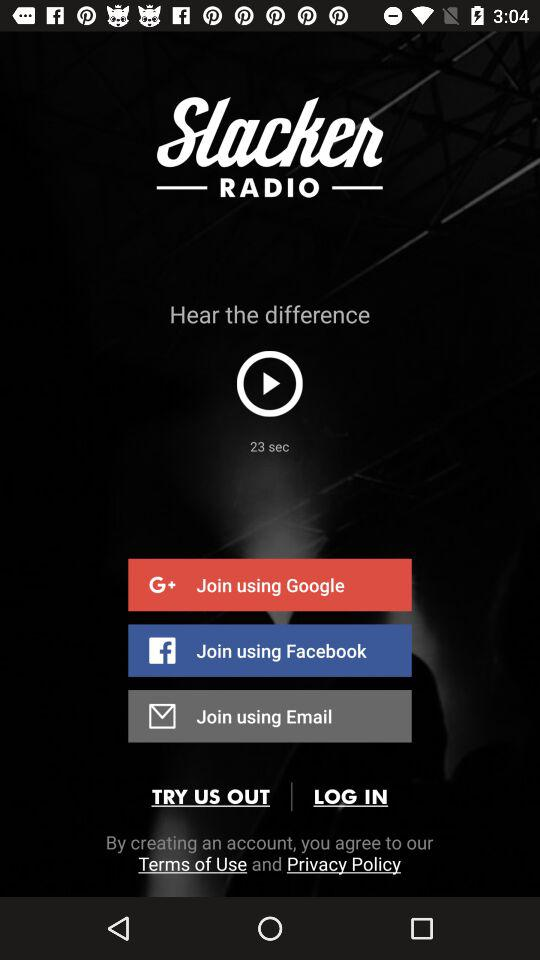What are the different options available for logging in? The different options for logging in are "Google", "Facebook", and "Email". 